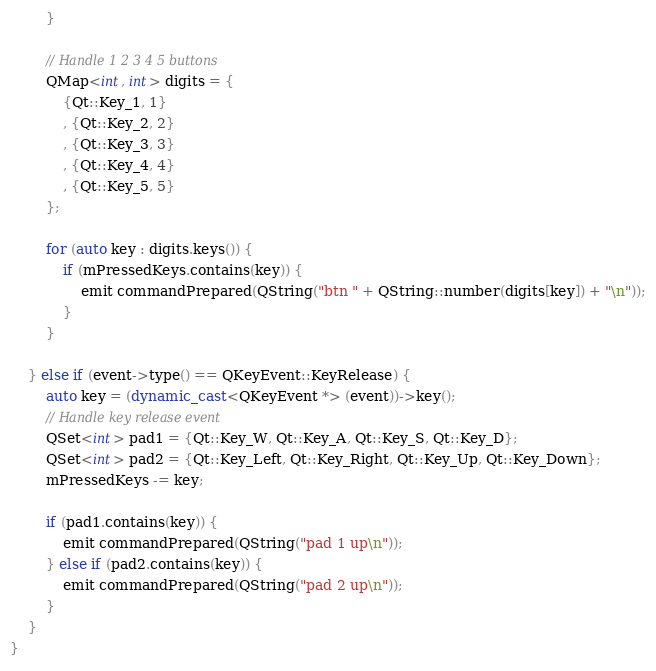Convert code to text. <code><loc_0><loc_0><loc_500><loc_500><_C++_>		}

		// Handle 1 2 3 4 5 buttons
		QMap<int, int> digits = {
			{Qt::Key_1, 1}
			, {Qt::Key_2, 2}
			, {Qt::Key_3, 3}
			, {Qt::Key_4, 4}
			, {Qt::Key_5, 5}
		};

		for (auto key : digits.keys()) {
			if (mPressedKeys.contains(key)) {
				emit commandPrepared(QString("btn " + QString::number(digits[key]) + "\n"));
			}
		}

	} else if (event->type() == QKeyEvent::KeyRelease) {
		auto key = (dynamic_cast<QKeyEvent *> (event))->key();
		// Handle key release event
		QSet<int> pad1 = {Qt::Key_W, Qt::Key_A, Qt::Key_S, Qt::Key_D};
		QSet<int> pad2 = {Qt::Key_Left, Qt::Key_Right, Qt::Key_Up, Qt::Key_Down};
		mPressedKeys -= key;

		if (pad1.contains(key)) {
			emit commandPrepared(QString("pad 1 up\n"));
		} else if (pad2.contains(key)) {
			emit commandPrepared(QString("pad 2 up\n"));
		}
	}
}
</code> 